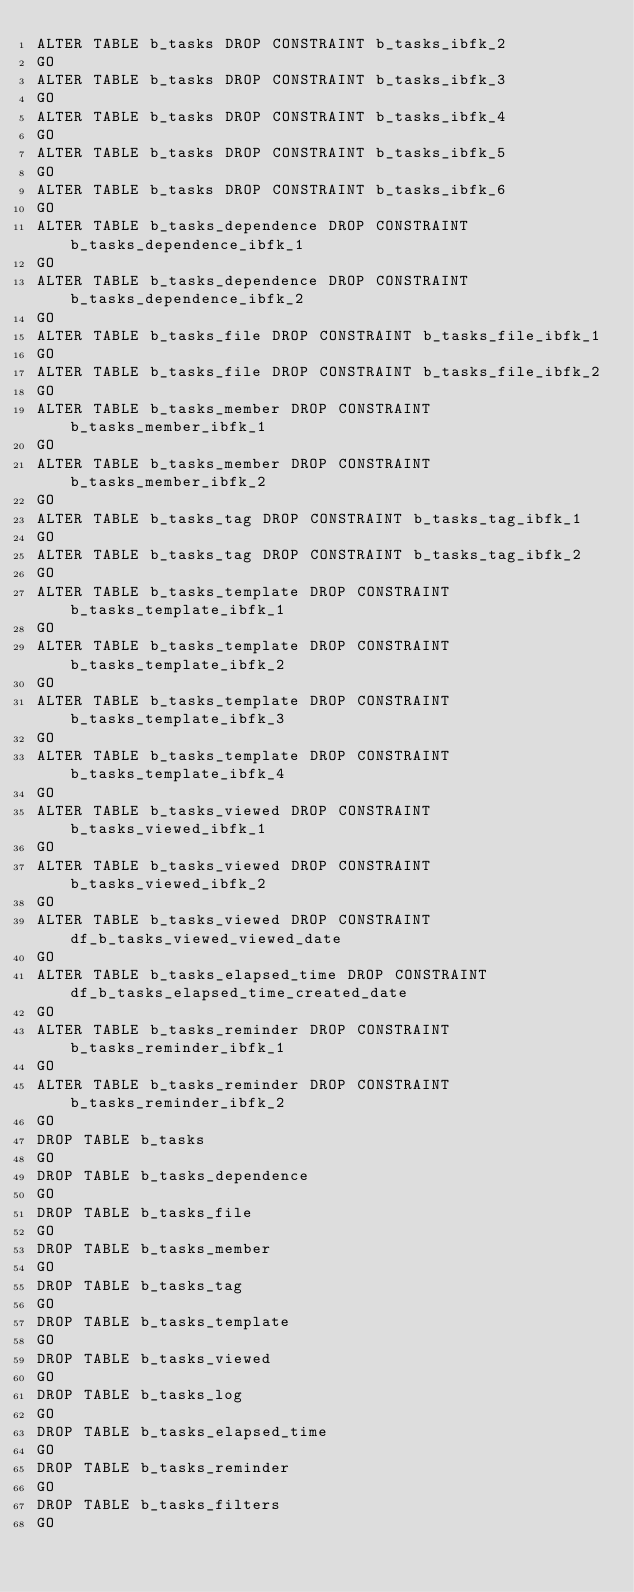Convert code to text. <code><loc_0><loc_0><loc_500><loc_500><_SQL_>ALTER TABLE b_tasks DROP CONSTRAINT b_tasks_ibfk_2
GO
ALTER TABLE b_tasks DROP CONSTRAINT b_tasks_ibfk_3
GO
ALTER TABLE b_tasks DROP CONSTRAINT b_tasks_ibfk_4
GO
ALTER TABLE b_tasks DROP CONSTRAINT b_tasks_ibfk_5
GO
ALTER TABLE b_tasks DROP CONSTRAINT b_tasks_ibfk_6
GO
ALTER TABLE b_tasks_dependence DROP CONSTRAINT b_tasks_dependence_ibfk_1
GO
ALTER TABLE b_tasks_dependence DROP CONSTRAINT b_tasks_dependence_ibfk_2
GO
ALTER TABLE b_tasks_file DROP CONSTRAINT b_tasks_file_ibfk_1
GO
ALTER TABLE b_tasks_file DROP CONSTRAINT b_tasks_file_ibfk_2
GO
ALTER TABLE b_tasks_member DROP CONSTRAINT b_tasks_member_ibfk_1
GO
ALTER TABLE b_tasks_member DROP CONSTRAINT b_tasks_member_ibfk_2
GO
ALTER TABLE b_tasks_tag DROP CONSTRAINT b_tasks_tag_ibfk_1
GO
ALTER TABLE b_tasks_tag DROP CONSTRAINT b_tasks_tag_ibfk_2
GO
ALTER TABLE b_tasks_template DROP CONSTRAINT b_tasks_template_ibfk_1
GO
ALTER TABLE b_tasks_template DROP CONSTRAINT b_tasks_template_ibfk_2
GO
ALTER TABLE b_tasks_template DROP CONSTRAINT b_tasks_template_ibfk_3
GO
ALTER TABLE b_tasks_template DROP CONSTRAINT b_tasks_template_ibfk_4
GO
ALTER TABLE b_tasks_viewed DROP CONSTRAINT b_tasks_viewed_ibfk_1
GO
ALTER TABLE b_tasks_viewed DROP CONSTRAINT b_tasks_viewed_ibfk_2
GO
ALTER TABLE b_tasks_viewed DROP CONSTRAINT df_b_tasks_viewed_viewed_date
GO
ALTER TABLE b_tasks_elapsed_time DROP CONSTRAINT df_b_tasks_elapsed_time_created_date
GO
ALTER TABLE b_tasks_reminder DROP CONSTRAINT b_tasks_reminder_ibfk_1
GO
ALTER TABLE b_tasks_reminder DROP CONSTRAINT b_tasks_reminder_ibfk_2
GO
DROP TABLE b_tasks
GO
DROP TABLE b_tasks_dependence
GO
DROP TABLE b_tasks_file
GO
DROP TABLE b_tasks_member
GO
DROP TABLE b_tasks_tag
GO
DROP TABLE b_tasks_template
GO
DROP TABLE b_tasks_viewed
GO
DROP TABLE b_tasks_log
GO
DROP TABLE b_tasks_elapsed_time
GO
DROP TABLE b_tasks_reminder
GO
DROP TABLE b_tasks_filters
GO
</code> 